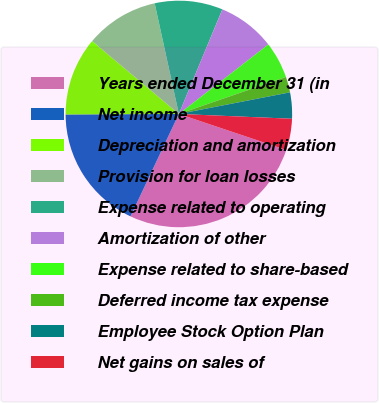Convert chart to OTSL. <chart><loc_0><loc_0><loc_500><loc_500><pie_chart><fcel>Years ended December 31 (in<fcel>Net income<fcel>Depreciation and amortization<fcel>Provision for loan losses<fcel>Expense related to operating<fcel>Amortization of other<fcel>Expense related to share-based<fcel>Deferred income tax expense<fcel>Employee Stock Option Plan<fcel>Net gains on sales of<nl><fcel>26.86%<fcel>17.91%<fcel>11.19%<fcel>10.45%<fcel>9.7%<fcel>8.21%<fcel>5.22%<fcel>2.24%<fcel>3.73%<fcel>4.48%<nl></chart> 